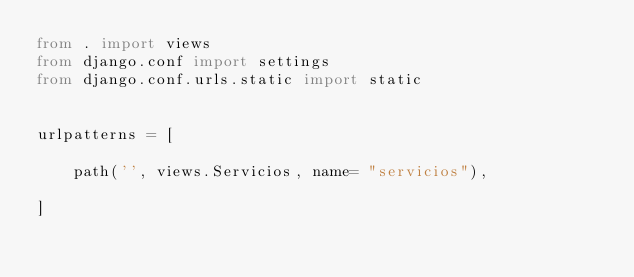<code> <loc_0><loc_0><loc_500><loc_500><_Python_>from . import views
from django.conf import settings
from django.conf.urls.static import static


urlpatterns = [
    
    path('', views.Servicios, name= "servicios"),
  
]

</code> 